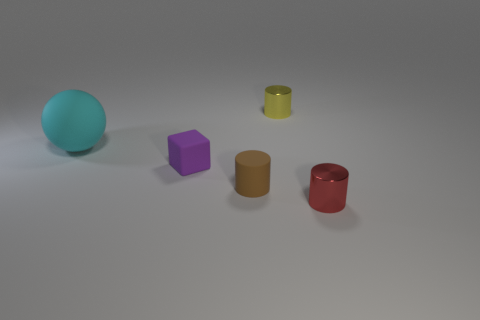There is a tiny red metallic object; are there any tiny yellow cylinders in front of it?
Provide a succinct answer. No. Do the yellow cylinder and the cyan sphere have the same size?
Offer a terse response. No. The tiny shiny thing behind the big rubber sphere has what shape?
Offer a very short reply. Cylinder. Are there any brown objects of the same size as the red metallic cylinder?
Your answer should be compact. Yes. What material is the brown cylinder that is the same size as the yellow metallic cylinder?
Make the answer very short. Rubber. There is a shiny cylinder in front of the big rubber ball; how big is it?
Offer a very short reply. Small. How big is the red cylinder?
Offer a terse response. Small. There is a cyan matte object; is it the same size as the rubber object that is in front of the purple rubber block?
Your answer should be compact. No. There is a thing that is to the right of the metallic object that is on the left side of the red metal object; what is its color?
Keep it short and to the point. Red. Is the number of small things that are to the right of the cyan thing the same as the number of tiny cylinders behind the tiny red object?
Provide a short and direct response. No. 